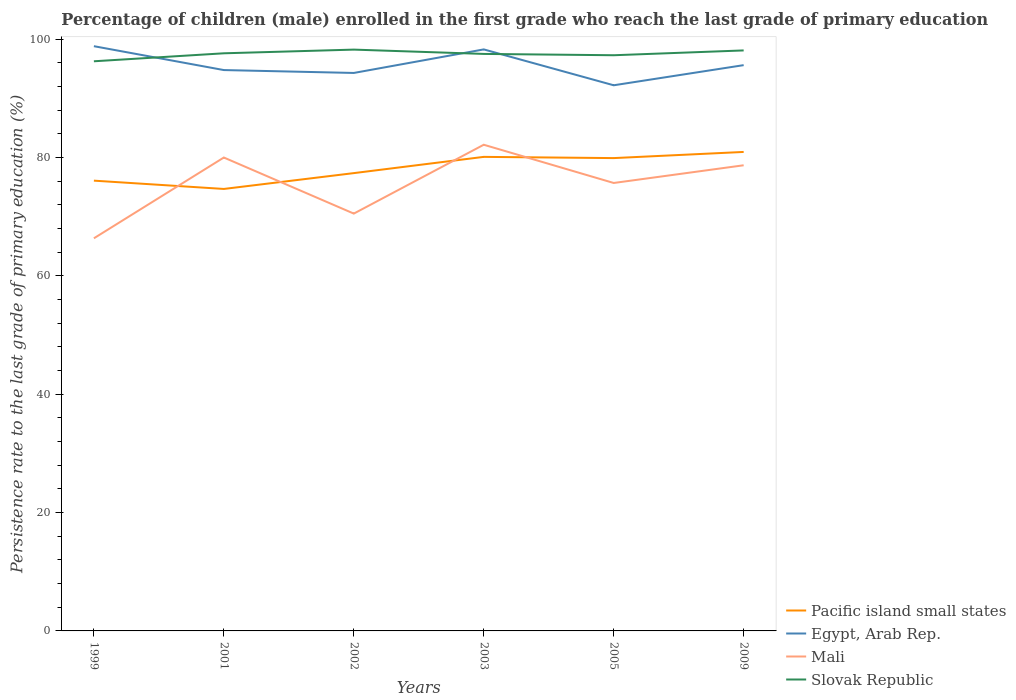Across all years, what is the maximum persistence rate of children in Slovak Republic?
Provide a short and direct response. 96.26. What is the total persistence rate of children in Mali in the graph?
Make the answer very short. -2.99. What is the difference between the highest and the second highest persistence rate of children in Pacific island small states?
Give a very brief answer. 6.25. What is the difference between the highest and the lowest persistence rate of children in Slovak Republic?
Ensure brevity in your answer.  4. How many years are there in the graph?
Ensure brevity in your answer.  6. Are the values on the major ticks of Y-axis written in scientific E-notation?
Ensure brevity in your answer.  No. Does the graph contain grids?
Your answer should be compact. No. Where does the legend appear in the graph?
Your answer should be very brief. Bottom right. How are the legend labels stacked?
Provide a short and direct response. Vertical. What is the title of the graph?
Your answer should be compact. Percentage of children (male) enrolled in the first grade who reach the last grade of primary education. What is the label or title of the X-axis?
Make the answer very short. Years. What is the label or title of the Y-axis?
Give a very brief answer. Persistence rate to the last grade of primary education (%). What is the Persistence rate to the last grade of primary education (%) in Pacific island small states in 1999?
Your answer should be compact. 76.08. What is the Persistence rate to the last grade of primary education (%) of Egypt, Arab Rep. in 1999?
Provide a short and direct response. 98.81. What is the Persistence rate to the last grade of primary education (%) in Mali in 1999?
Your answer should be compact. 66.34. What is the Persistence rate to the last grade of primary education (%) of Slovak Republic in 1999?
Provide a succinct answer. 96.26. What is the Persistence rate to the last grade of primary education (%) of Pacific island small states in 2001?
Make the answer very short. 74.68. What is the Persistence rate to the last grade of primary education (%) in Egypt, Arab Rep. in 2001?
Ensure brevity in your answer.  94.77. What is the Persistence rate to the last grade of primary education (%) in Mali in 2001?
Your answer should be compact. 79.99. What is the Persistence rate to the last grade of primary education (%) in Slovak Republic in 2001?
Provide a succinct answer. 97.6. What is the Persistence rate to the last grade of primary education (%) in Pacific island small states in 2002?
Ensure brevity in your answer.  77.36. What is the Persistence rate to the last grade of primary education (%) in Egypt, Arab Rep. in 2002?
Your answer should be very brief. 94.28. What is the Persistence rate to the last grade of primary education (%) in Mali in 2002?
Your response must be concise. 70.52. What is the Persistence rate to the last grade of primary education (%) in Slovak Republic in 2002?
Keep it short and to the point. 98.23. What is the Persistence rate to the last grade of primary education (%) in Pacific island small states in 2003?
Provide a succinct answer. 80.1. What is the Persistence rate to the last grade of primary education (%) of Egypt, Arab Rep. in 2003?
Give a very brief answer. 98.26. What is the Persistence rate to the last grade of primary education (%) in Mali in 2003?
Your answer should be compact. 82.15. What is the Persistence rate to the last grade of primary education (%) of Slovak Republic in 2003?
Provide a short and direct response. 97.5. What is the Persistence rate to the last grade of primary education (%) of Pacific island small states in 2005?
Your response must be concise. 79.89. What is the Persistence rate to the last grade of primary education (%) in Egypt, Arab Rep. in 2005?
Your answer should be compact. 92.2. What is the Persistence rate to the last grade of primary education (%) in Mali in 2005?
Keep it short and to the point. 75.69. What is the Persistence rate to the last grade of primary education (%) in Slovak Republic in 2005?
Your response must be concise. 97.27. What is the Persistence rate to the last grade of primary education (%) in Pacific island small states in 2009?
Your answer should be very brief. 80.94. What is the Persistence rate to the last grade of primary education (%) of Egypt, Arab Rep. in 2009?
Keep it short and to the point. 95.6. What is the Persistence rate to the last grade of primary education (%) of Mali in 2009?
Keep it short and to the point. 78.68. What is the Persistence rate to the last grade of primary education (%) in Slovak Republic in 2009?
Provide a short and direct response. 98.09. Across all years, what is the maximum Persistence rate to the last grade of primary education (%) of Pacific island small states?
Provide a succinct answer. 80.94. Across all years, what is the maximum Persistence rate to the last grade of primary education (%) of Egypt, Arab Rep.?
Provide a short and direct response. 98.81. Across all years, what is the maximum Persistence rate to the last grade of primary education (%) of Mali?
Provide a succinct answer. 82.15. Across all years, what is the maximum Persistence rate to the last grade of primary education (%) in Slovak Republic?
Make the answer very short. 98.23. Across all years, what is the minimum Persistence rate to the last grade of primary education (%) of Pacific island small states?
Your response must be concise. 74.68. Across all years, what is the minimum Persistence rate to the last grade of primary education (%) in Egypt, Arab Rep.?
Make the answer very short. 92.2. Across all years, what is the minimum Persistence rate to the last grade of primary education (%) in Mali?
Keep it short and to the point. 66.34. Across all years, what is the minimum Persistence rate to the last grade of primary education (%) in Slovak Republic?
Provide a short and direct response. 96.26. What is the total Persistence rate to the last grade of primary education (%) of Pacific island small states in the graph?
Offer a terse response. 469.05. What is the total Persistence rate to the last grade of primary education (%) in Egypt, Arab Rep. in the graph?
Keep it short and to the point. 573.92. What is the total Persistence rate to the last grade of primary education (%) in Mali in the graph?
Your answer should be very brief. 453.38. What is the total Persistence rate to the last grade of primary education (%) of Slovak Republic in the graph?
Keep it short and to the point. 584.95. What is the difference between the Persistence rate to the last grade of primary education (%) in Pacific island small states in 1999 and that in 2001?
Make the answer very short. 1.4. What is the difference between the Persistence rate to the last grade of primary education (%) of Egypt, Arab Rep. in 1999 and that in 2001?
Offer a very short reply. 4.04. What is the difference between the Persistence rate to the last grade of primary education (%) in Mali in 1999 and that in 2001?
Keep it short and to the point. -13.65. What is the difference between the Persistence rate to the last grade of primary education (%) of Slovak Republic in 1999 and that in 2001?
Offer a terse response. -1.35. What is the difference between the Persistence rate to the last grade of primary education (%) of Pacific island small states in 1999 and that in 2002?
Make the answer very short. -1.27. What is the difference between the Persistence rate to the last grade of primary education (%) of Egypt, Arab Rep. in 1999 and that in 2002?
Ensure brevity in your answer.  4.52. What is the difference between the Persistence rate to the last grade of primary education (%) of Mali in 1999 and that in 2002?
Your answer should be very brief. -4.18. What is the difference between the Persistence rate to the last grade of primary education (%) of Slovak Republic in 1999 and that in 2002?
Give a very brief answer. -1.97. What is the difference between the Persistence rate to the last grade of primary education (%) in Pacific island small states in 1999 and that in 2003?
Offer a terse response. -4.02. What is the difference between the Persistence rate to the last grade of primary education (%) in Egypt, Arab Rep. in 1999 and that in 2003?
Your answer should be compact. 0.54. What is the difference between the Persistence rate to the last grade of primary education (%) in Mali in 1999 and that in 2003?
Offer a terse response. -15.81. What is the difference between the Persistence rate to the last grade of primary education (%) in Slovak Republic in 1999 and that in 2003?
Your response must be concise. -1.24. What is the difference between the Persistence rate to the last grade of primary education (%) in Pacific island small states in 1999 and that in 2005?
Keep it short and to the point. -3.81. What is the difference between the Persistence rate to the last grade of primary education (%) in Egypt, Arab Rep. in 1999 and that in 2005?
Your response must be concise. 6.61. What is the difference between the Persistence rate to the last grade of primary education (%) in Mali in 1999 and that in 2005?
Provide a short and direct response. -9.35. What is the difference between the Persistence rate to the last grade of primary education (%) of Slovak Republic in 1999 and that in 2005?
Make the answer very short. -1.02. What is the difference between the Persistence rate to the last grade of primary education (%) in Pacific island small states in 1999 and that in 2009?
Make the answer very short. -4.85. What is the difference between the Persistence rate to the last grade of primary education (%) of Egypt, Arab Rep. in 1999 and that in 2009?
Keep it short and to the point. 3.2. What is the difference between the Persistence rate to the last grade of primary education (%) of Mali in 1999 and that in 2009?
Your answer should be very brief. -12.34. What is the difference between the Persistence rate to the last grade of primary education (%) in Slovak Republic in 1999 and that in 2009?
Offer a very short reply. -1.84. What is the difference between the Persistence rate to the last grade of primary education (%) of Pacific island small states in 2001 and that in 2002?
Provide a short and direct response. -2.67. What is the difference between the Persistence rate to the last grade of primary education (%) in Egypt, Arab Rep. in 2001 and that in 2002?
Keep it short and to the point. 0.49. What is the difference between the Persistence rate to the last grade of primary education (%) in Mali in 2001 and that in 2002?
Offer a very short reply. 9.48. What is the difference between the Persistence rate to the last grade of primary education (%) in Slovak Republic in 2001 and that in 2002?
Provide a succinct answer. -0.62. What is the difference between the Persistence rate to the last grade of primary education (%) of Pacific island small states in 2001 and that in 2003?
Make the answer very short. -5.42. What is the difference between the Persistence rate to the last grade of primary education (%) in Egypt, Arab Rep. in 2001 and that in 2003?
Ensure brevity in your answer.  -3.49. What is the difference between the Persistence rate to the last grade of primary education (%) of Mali in 2001 and that in 2003?
Offer a very short reply. -2.16. What is the difference between the Persistence rate to the last grade of primary education (%) of Slovak Republic in 2001 and that in 2003?
Offer a very short reply. 0.11. What is the difference between the Persistence rate to the last grade of primary education (%) of Pacific island small states in 2001 and that in 2005?
Give a very brief answer. -5.21. What is the difference between the Persistence rate to the last grade of primary education (%) of Egypt, Arab Rep. in 2001 and that in 2005?
Offer a very short reply. 2.57. What is the difference between the Persistence rate to the last grade of primary education (%) in Mali in 2001 and that in 2005?
Your answer should be very brief. 4.3. What is the difference between the Persistence rate to the last grade of primary education (%) of Slovak Republic in 2001 and that in 2005?
Give a very brief answer. 0.33. What is the difference between the Persistence rate to the last grade of primary education (%) of Pacific island small states in 2001 and that in 2009?
Your answer should be very brief. -6.25. What is the difference between the Persistence rate to the last grade of primary education (%) of Egypt, Arab Rep. in 2001 and that in 2009?
Offer a very short reply. -0.83. What is the difference between the Persistence rate to the last grade of primary education (%) of Mali in 2001 and that in 2009?
Keep it short and to the point. 1.31. What is the difference between the Persistence rate to the last grade of primary education (%) of Slovak Republic in 2001 and that in 2009?
Your response must be concise. -0.49. What is the difference between the Persistence rate to the last grade of primary education (%) of Pacific island small states in 2002 and that in 2003?
Give a very brief answer. -2.75. What is the difference between the Persistence rate to the last grade of primary education (%) of Egypt, Arab Rep. in 2002 and that in 2003?
Give a very brief answer. -3.98. What is the difference between the Persistence rate to the last grade of primary education (%) in Mali in 2002 and that in 2003?
Offer a terse response. -11.63. What is the difference between the Persistence rate to the last grade of primary education (%) in Slovak Republic in 2002 and that in 2003?
Your answer should be very brief. 0.73. What is the difference between the Persistence rate to the last grade of primary education (%) in Pacific island small states in 2002 and that in 2005?
Provide a succinct answer. -2.54. What is the difference between the Persistence rate to the last grade of primary education (%) in Egypt, Arab Rep. in 2002 and that in 2005?
Ensure brevity in your answer.  2.08. What is the difference between the Persistence rate to the last grade of primary education (%) in Mali in 2002 and that in 2005?
Ensure brevity in your answer.  -5.17. What is the difference between the Persistence rate to the last grade of primary education (%) in Slovak Republic in 2002 and that in 2005?
Provide a succinct answer. 0.95. What is the difference between the Persistence rate to the last grade of primary education (%) of Pacific island small states in 2002 and that in 2009?
Offer a very short reply. -3.58. What is the difference between the Persistence rate to the last grade of primary education (%) in Egypt, Arab Rep. in 2002 and that in 2009?
Keep it short and to the point. -1.32. What is the difference between the Persistence rate to the last grade of primary education (%) of Mali in 2002 and that in 2009?
Your answer should be compact. -8.17. What is the difference between the Persistence rate to the last grade of primary education (%) of Slovak Republic in 2002 and that in 2009?
Ensure brevity in your answer.  0.14. What is the difference between the Persistence rate to the last grade of primary education (%) of Pacific island small states in 2003 and that in 2005?
Offer a terse response. 0.21. What is the difference between the Persistence rate to the last grade of primary education (%) of Egypt, Arab Rep. in 2003 and that in 2005?
Your answer should be very brief. 6.06. What is the difference between the Persistence rate to the last grade of primary education (%) in Mali in 2003 and that in 2005?
Offer a very short reply. 6.46. What is the difference between the Persistence rate to the last grade of primary education (%) of Slovak Republic in 2003 and that in 2005?
Offer a very short reply. 0.22. What is the difference between the Persistence rate to the last grade of primary education (%) in Pacific island small states in 2003 and that in 2009?
Make the answer very short. -0.83. What is the difference between the Persistence rate to the last grade of primary education (%) in Egypt, Arab Rep. in 2003 and that in 2009?
Your answer should be very brief. 2.66. What is the difference between the Persistence rate to the last grade of primary education (%) in Mali in 2003 and that in 2009?
Provide a succinct answer. 3.47. What is the difference between the Persistence rate to the last grade of primary education (%) in Slovak Republic in 2003 and that in 2009?
Offer a terse response. -0.59. What is the difference between the Persistence rate to the last grade of primary education (%) of Pacific island small states in 2005 and that in 2009?
Keep it short and to the point. -1.04. What is the difference between the Persistence rate to the last grade of primary education (%) of Egypt, Arab Rep. in 2005 and that in 2009?
Give a very brief answer. -3.4. What is the difference between the Persistence rate to the last grade of primary education (%) in Mali in 2005 and that in 2009?
Your answer should be very brief. -2.99. What is the difference between the Persistence rate to the last grade of primary education (%) of Slovak Republic in 2005 and that in 2009?
Give a very brief answer. -0.82. What is the difference between the Persistence rate to the last grade of primary education (%) in Pacific island small states in 1999 and the Persistence rate to the last grade of primary education (%) in Egypt, Arab Rep. in 2001?
Ensure brevity in your answer.  -18.69. What is the difference between the Persistence rate to the last grade of primary education (%) of Pacific island small states in 1999 and the Persistence rate to the last grade of primary education (%) of Mali in 2001?
Provide a short and direct response. -3.91. What is the difference between the Persistence rate to the last grade of primary education (%) of Pacific island small states in 1999 and the Persistence rate to the last grade of primary education (%) of Slovak Republic in 2001?
Ensure brevity in your answer.  -21.52. What is the difference between the Persistence rate to the last grade of primary education (%) of Egypt, Arab Rep. in 1999 and the Persistence rate to the last grade of primary education (%) of Mali in 2001?
Your response must be concise. 18.81. What is the difference between the Persistence rate to the last grade of primary education (%) in Egypt, Arab Rep. in 1999 and the Persistence rate to the last grade of primary education (%) in Slovak Republic in 2001?
Your answer should be compact. 1.2. What is the difference between the Persistence rate to the last grade of primary education (%) in Mali in 1999 and the Persistence rate to the last grade of primary education (%) in Slovak Republic in 2001?
Your answer should be compact. -31.26. What is the difference between the Persistence rate to the last grade of primary education (%) in Pacific island small states in 1999 and the Persistence rate to the last grade of primary education (%) in Egypt, Arab Rep. in 2002?
Make the answer very short. -18.2. What is the difference between the Persistence rate to the last grade of primary education (%) of Pacific island small states in 1999 and the Persistence rate to the last grade of primary education (%) of Mali in 2002?
Make the answer very short. 5.57. What is the difference between the Persistence rate to the last grade of primary education (%) in Pacific island small states in 1999 and the Persistence rate to the last grade of primary education (%) in Slovak Republic in 2002?
Keep it short and to the point. -22.14. What is the difference between the Persistence rate to the last grade of primary education (%) in Egypt, Arab Rep. in 1999 and the Persistence rate to the last grade of primary education (%) in Mali in 2002?
Offer a very short reply. 28.29. What is the difference between the Persistence rate to the last grade of primary education (%) in Egypt, Arab Rep. in 1999 and the Persistence rate to the last grade of primary education (%) in Slovak Republic in 2002?
Your answer should be compact. 0.58. What is the difference between the Persistence rate to the last grade of primary education (%) in Mali in 1999 and the Persistence rate to the last grade of primary education (%) in Slovak Republic in 2002?
Make the answer very short. -31.88. What is the difference between the Persistence rate to the last grade of primary education (%) of Pacific island small states in 1999 and the Persistence rate to the last grade of primary education (%) of Egypt, Arab Rep. in 2003?
Your response must be concise. -22.18. What is the difference between the Persistence rate to the last grade of primary education (%) in Pacific island small states in 1999 and the Persistence rate to the last grade of primary education (%) in Mali in 2003?
Give a very brief answer. -6.07. What is the difference between the Persistence rate to the last grade of primary education (%) of Pacific island small states in 1999 and the Persistence rate to the last grade of primary education (%) of Slovak Republic in 2003?
Ensure brevity in your answer.  -21.41. What is the difference between the Persistence rate to the last grade of primary education (%) in Egypt, Arab Rep. in 1999 and the Persistence rate to the last grade of primary education (%) in Mali in 2003?
Provide a succinct answer. 16.65. What is the difference between the Persistence rate to the last grade of primary education (%) in Egypt, Arab Rep. in 1999 and the Persistence rate to the last grade of primary education (%) in Slovak Republic in 2003?
Make the answer very short. 1.31. What is the difference between the Persistence rate to the last grade of primary education (%) in Mali in 1999 and the Persistence rate to the last grade of primary education (%) in Slovak Republic in 2003?
Provide a short and direct response. -31.16. What is the difference between the Persistence rate to the last grade of primary education (%) of Pacific island small states in 1999 and the Persistence rate to the last grade of primary education (%) of Egypt, Arab Rep. in 2005?
Provide a succinct answer. -16.12. What is the difference between the Persistence rate to the last grade of primary education (%) of Pacific island small states in 1999 and the Persistence rate to the last grade of primary education (%) of Mali in 2005?
Make the answer very short. 0.39. What is the difference between the Persistence rate to the last grade of primary education (%) of Pacific island small states in 1999 and the Persistence rate to the last grade of primary education (%) of Slovak Republic in 2005?
Provide a short and direct response. -21.19. What is the difference between the Persistence rate to the last grade of primary education (%) in Egypt, Arab Rep. in 1999 and the Persistence rate to the last grade of primary education (%) in Mali in 2005?
Offer a very short reply. 23.11. What is the difference between the Persistence rate to the last grade of primary education (%) of Egypt, Arab Rep. in 1999 and the Persistence rate to the last grade of primary education (%) of Slovak Republic in 2005?
Your answer should be very brief. 1.53. What is the difference between the Persistence rate to the last grade of primary education (%) in Mali in 1999 and the Persistence rate to the last grade of primary education (%) in Slovak Republic in 2005?
Your answer should be very brief. -30.93. What is the difference between the Persistence rate to the last grade of primary education (%) of Pacific island small states in 1999 and the Persistence rate to the last grade of primary education (%) of Egypt, Arab Rep. in 2009?
Make the answer very short. -19.52. What is the difference between the Persistence rate to the last grade of primary education (%) in Pacific island small states in 1999 and the Persistence rate to the last grade of primary education (%) in Mali in 2009?
Ensure brevity in your answer.  -2.6. What is the difference between the Persistence rate to the last grade of primary education (%) in Pacific island small states in 1999 and the Persistence rate to the last grade of primary education (%) in Slovak Republic in 2009?
Offer a terse response. -22.01. What is the difference between the Persistence rate to the last grade of primary education (%) in Egypt, Arab Rep. in 1999 and the Persistence rate to the last grade of primary education (%) in Mali in 2009?
Offer a very short reply. 20.12. What is the difference between the Persistence rate to the last grade of primary education (%) in Egypt, Arab Rep. in 1999 and the Persistence rate to the last grade of primary education (%) in Slovak Republic in 2009?
Provide a succinct answer. 0.72. What is the difference between the Persistence rate to the last grade of primary education (%) in Mali in 1999 and the Persistence rate to the last grade of primary education (%) in Slovak Republic in 2009?
Provide a short and direct response. -31.75. What is the difference between the Persistence rate to the last grade of primary education (%) in Pacific island small states in 2001 and the Persistence rate to the last grade of primary education (%) in Egypt, Arab Rep. in 2002?
Make the answer very short. -19.6. What is the difference between the Persistence rate to the last grade of primary education (%) of Pacific island small states in 2001 and the Persistence rate to the last grade of primary education (%) of Mali in 2002?
Offer a very short reply. 4.17. What is the difference between the Persistence rate to the last grade of primary education (%) of Pacific island small states in 2001 and the Persistence rate to the last grade of primary education (%) of Slovak Republic in 2002?
Ensure brevity in your answer.  -23.54. What is the difference between the Persistence rate to the last grade of primary education (%) in Egypt, Arab Rep. in 2001 and the Persistence rate to the last grade of primary education (%) in Mali in 2002?
Your answer should be very brief. 24.25. What is the difference between the Persistence rate to the last grade of primary education (%) of Egypt, Arab Rep. in 2001 and the Persistence rate to the last grade of primary education (%) of Slovak Republic in 2002?
Keep it short and to the point. -3.46. What is the difference between the Persistence rate to the last grade of primary education (%) of Mali in 2001 and the Persistence rate to the last grade of primary education (%) of Slovak Republic in 2002?
Give a very brief answer. -18.23. What is the difference between the Persistence rate to the last grade of primary education (%) in Pacific island small states in 2001 and the Persistence rate to the last grade of primary education (%) in Egypt, Arab Rep. in 2003?
Ensure brevity in your answer.  -23.58. What is the difference between the Persistence rate to the last grade of primary education (%) of Pacific island small states in 2001 and the Persistence rate to the last grade of primary education (%) of Mali in 2003?
Your answer should be compact. -7.47. What is the difference between the Persistence rate to the last grade of primary education (%) of Pacific island small states in 2001 and the Persistence rate to the last grade of primary education (%) of Slovak Republic in 2003?
Your answer should be compact. -22.82. What is the difference between the Persistence rate to the last grade of primary education (%) of Egypt, Arab Rep. in 2001 and the Persistence rate to the last grade of primary education (%) of Mali in 2003?
Your answer should be compact. 12.62. What is the difference between the Persistence rate to the last grade of primary education (%) in Egypt, Arab Rep. in 2001 and the Persistence rate to the last grade of primary education (%) in Slovak Republic in 2003?
Make the answer very short. -2.73. What is the difference between the Persistence rate to the last grade of primary education (%) of Mali in 2001 and the Persistence rate to the last grade of primary education (%) of Slovak Republic in 2003?
Your answer should be compact. -17.5. What is the difference between the Persistence rate to the last grade of primary education (%) of Pacific island small states in 2001 and the Persistence rate to the last grade of primary education (%) of Egypt, Arab Rep. in 2005?
Ensure brevity in your answer.  -17.52. What is the difference between the Persistence rate to the last grade of primary education (%) of Pacific island small states in 2001 and the Persistence rate to the last grade of primary education (%) of Mali in 2005?
Provide a short and direct response. -1.01. What is the difference between the Persistence rate to the last grade of primary education (%) of Pacific island small states in 2001 and the Persistence rate to the last grade of primary education (%) of Slovak Republic in 2005?
Give a very brief answer. -22.59. What is the difference between the Persistence rate to the last grade of primary education (%) of Egypt, Arab Rep. in 2001 and the Persistence rate to the last grade of primary education (%) of Mali in 2005?
Keep it short and to the point. 19.08. What is the difference between the Persistence rate to the last grade of primary education (%) of Egypt, Arab Rep. in 2001 and the Persistence rate to the last grade of primary education (%) of Slovak Republic in 2005?
Make the answer very short. -2.5. What is the difference between the Persistence rate to the last grade of primary education (%) of Mali in 2001 and the Persistence rate to the last grade of primary education (%) of Slovak Republic in 2005?
Your answer should be very brief. -17.28. What is the difference between the Persistence rate to the last grade of primary education (%) in Pacific island small states in 2001 and the Persistence rate to the last grade of primary education (%) in Egypt, Arab Rep. in 2009?
Provide a succinct answer. -20.92. What is the difference between the Persistence rate to the last grade of primary education (%) in Pacific island small states in 2001 and the Persistence rate to the last grade of primary education (%) in Mali in 2009?
Provide a succinct answer. -4. What is the difference between the Persistence rate to the last grade of primary education (%) of Pacific island small states in 2001 and the Persistence rate to the last grade of primary education (%) of Slovak Republic in 2009?
Provide a succinct answer. -23.41. What is the difference between the Persistence rate to the last grade of primary education (%) in Egypt, Arab Rep. in 2001 and the Persistence rate to the last grade of primary education (%) in Mali in 2009?
Your answer should be compact. 16.09. What is the difference between the Persistence rate to the last grade of primary education (%) in Egypt, Arab Rep. in 2001 and the Persistence rate to the last grade of primary education (%) in Slovak Republic in 2009?
Your answer should be compact. -3.32. What is the difference between the Persistence rate to the last grade of primary education (%) of Mali in 2001 and the Persistence rate to the last grade of primary education (%) of Slovak Republic in 2009?
Your answer should be very brief. -18.1. What is the difference between the Persistence rate to the last grade of primary education (%) in Pacific island small states in 2002 and the Persistence rate to the last grade of primary education (%) in Egypt, Arab Rep. in 2003?
Your answer should be very brief. -20.91. What is the difference between the Persistence rate to the last grade of primary education (%) of Pacific island small states in 2002 and the Persistence rate to the last grade of primary education (%) of Mali in 2003?
Your response must be concise. -4.79. What is the difference between the Persistence rate to the last grade of primary education (%) in Pacific island small states in 2002 and the Persistence rate to the last grade of primary education (%) in Slovak Republic in 2003?
Your response must be concise. -20.14. What is the difference between the Persistence rate to the last grade of primary education (%) in Egypt, Arab Rep. in 2002 and the Persistence rate to the last grade of primary education (%) in Mali in 2003?
Make the answer very short. 12.13. What is the difference between the Persistence rate to the last grade of primary education (%) of Egypt, Arab Rep. in 2002 and the Persistence rate to the last grade of primary education (%) of Slovak Republic in 2003?
Give a very brief answer. -3.22. What is the difference between the Persistence rate to the last grade of primary education (%) of Mali in 2002 and the Persistence rate to the last grade of primary education (%) of Slovak Republic in 2003?
Ensure brevity in your answer.  -26.98. What is the difference between the Persistence rate to the last grade of primary education (%) of Pacific island small states in 2002 and the Persistence rate to the last grade of primary education (%) of Egypt, Arab Rep. in 2005?
Give a very brief answer. -14.84. What is the difference between the Persistence rate to the last grade of primary education (%) of Pacific island small states in 2002 and the Persistence rate to the last grade of primary education (%) of Mali in 2005?
Offer a terse response. 1.66. What is the difference between the Persistence rate to the last grade of primary education (%) of Pacific island small states in 2002 and the Persistence rate to the last grade of primary education (%) of Slovak Republic in 2005?
Offer a very short reply. -19.92. What is the difference between the Persistence rate to the last grade of primary education (%) of Egypt, Arab Rep. in 2002 and the Persistence rate to the last grade of primary education (%) of Mali in 2005?
Your answer should be very brief. 18.59. What is the difference between the Persistence rate to the last grade of primary education (%) in Egypt, Arab Rep. in 2002 and the Persistence rate to the last grade of primary education (%) in Slovak Republic in 2005?
Your answer should be compact. -2.99. What is the difference between the Persistence rate to the last grade of primary education (%) of Mali in 2002 and the Persistence rate to the last grade of primary education (%) of Slovak Republic in 2005?
Ensure brevity in your answer.  -26.76. What is the difference between the Persistence rate to the last grade of primary education (%) of Pacific island small states in 2002 and the Persistence rate to the last grade of primary education (%) of Egypt, Arab Rep. in 2009?
Offer a very short reply. -18.25. What is the difference between the Persistence rate to the last grade of primary education (%) in Pacific island small states in 2002 and the Persistence rate to the last grade of primary education (%) in Mali in 2009?
Offer a terse response. -1.33. What is the difference between the Persistence rate to the last grade of primary education (%) of Pacific island small states in 2002 and the Persistence rate to the last grade of primary education (%) of Slovak Republic in 2009?
Provide a succinct answer. -20.73. What is the difference between the Persistence rate to the last grade of primary education (%) in Egypt, Arab Rep. in 2002 and the Persistence rate to the last grade of primary education (%) in Mali in 2009?
Make the answer very short. 15.6. What is the difference between the Persistence rate to the last grade of primary education (%) of Egypt, Arab Rep. in 2002 and the Persistence rate to the last grade of primary education (%) of Slovak Republic in 2009?
Your answer should be very brief. -3.81. What is the difference between the Persistence rate to the last grade of primary education (%) in Mali in 2002 and the Persistence rate to the last grade of primary education (%) in Slovak Republic in 2009?
Give a very brief answer. -27.57. What is the difference between the Persistence rate to the last grade of primary education (%) in Pacific island small states in 2003 and the Persistence rate to the last grade of primary education (%) in Egypt, Arab Rep. in 2005?
Your response must be concise. -12.1. What is the difference between the Persistence rate to the last grade of primary education (%) in Pacific island small states in 2003 and the Persistence rate to the last grade of primary education (%) in Mali in 2005?
Provide a succinct answer. 4.41. What is the difference between the Persistence rate to the last grade of primary education (%) in Pacific island small states in 2003 and the Persistence rate to the last grade of primary education (%) in Slovak Republic in 2005?
Make the answer very short. -17.17. What is the difference between the Persistence rate to the last grade of primary education (%) in Egypt, Arab Rep. in 2003 and the Persistence rate to the last grade of primary education (%) in Mali in 2005?
Make the answer very short. 22.57. What is the difference between the Persistence rate to the last grade of primary education (%) in Egypt, Arab Rep. in 2003 and the Persistence rate to the last grade of primary education (%) in Slovak Republic in 2005?
Provide a succinct answer. 0.99. What is the difference between the Persistence rate to the last grade of primary education (%) in Mali in 2003 and the Persistence rate to the last grade of primary education (%) in Slovak Republic in 2005?
Give a very brief answer. -15.12. What is the difference between the Persistence rate to the last grade of primary education (%) of Pacific island small states in 2003 and the Persistence rate to the last grade of primary education (%) of Egypt, Arab Rep. in 2009?
Your answer should be very brief. -15.5. What is the difference between the Persistence rate to the last grade of primary education (%) in Pacific island small states in 2003 and the Persistence rate to the last grade of primary education (%) in Mali in 2009?
Offer a terse response. 1.42. What is the difference between the Persistence rate to the last grade of primary education (%) in Pacific island small states in 2003 and the Persistence rate to the last grade of primary education (%) in Slovak Republic in 2009?
Ensure brevity in your answer.  -17.99. What is the difference between the Persistence rate to the last grade of primary education (%) of Egypt, Arab Rep. in 2003 and the Persistence rate to the last grade of primary education (%) of Mali in 2009?
Make the answer very short. 19.58. What is the difference between the Persistence rate to the last grade of primary education (%) in Egypt, Arab Rep. in 2003 and the Persistence rate to the last grade of primary education (%) in Slovak Republic in 2009?
Ensure brevity in your answer.  0.17. What is the difference between the Persistence rate to the last grade of primary education (%) of Mali in 2003 and the Persistence rate to the last grade of primary education (%) of Slovak Republic in 2009?
Offer a terse response. -15.94. What is the difference between the Persistence rate to the last grade of primary education (%) in Pacific island small states in 2005 and the Persistence rate to the last grade of primary education (%) in Egypt, Arab Rep. in 2009?
Provide a succinct answer. -15.71. What is the difference between the Persistence rate to the last grade of primary education (%) of Pacific island small states in 2005 and the Persistence rate to the last grade of primary education (%) of Mali in 2009?
Your answer should be compact. 1.21. What is the difference between the Persistence rate to the last grade of primary education (%) of Pacific island small states in 2005 and the Persistence rate to the last grade of primary education (%) of Slovak Republic in 2009?
Make the answer very short. -18.2. What is the difference between the Persistence rate to the last grade of primary education (%) of Egypt, Arab Rep. in 2005 and the Persistence rate to the last grade of primary education (%) of Mali in 2009?
Ensure brevity in your answer.  13.52. What is the difference between the Persistence rate to the last grade of primary education (%) of Egypt, Arab Rep. in 2005 and the Persistence rate to the last grade of primary education (%) of Slovak Republic in 2009?
Offer a very short reply. -5.89. What is the difference between the Persistence rate to the last grade of primary education (%) in Mali in 2005 and the Persistence rate to the last grade of primary education (%) in Slovak Republic in 2009?
Your response must be concise. -22.4. What is the average Persistence rate to the last grade of primary education (%) of Pacific island small states per year?
Offer a very short reply. 78.18. What is the average Persistence rate to the last grade of primary education (%) in Egypt, Arab Rep. per year?
Ensure brevity in your answer.  95.65. What is the average Persistence rate to the last grade of primary education (%) in Mali per year?
Give a very brief answer. 75.56. What is the average Persistence rate to the last grade of primary education (%) of Slovak Republic per year?
Your response must be concise. 97.49. In the year 1999, what is the difference between the Persistence rate to the last grade of primary education (%) of Pacific island small states and Persistence rate to the last grade of primary education (%) of Egypt, Arab Rep.?
Your answer should be very brief. -22.72. In the year 1999, what is the difference between the Persistence rate to the last grade of primary education (%) of Pacific island small states and Persistence rate to the last grade of primary education (%) of Mali?
Provide a succinct answer. 9.74. In the year 1999, what is the difference between the Persistence rate to the last grade of primary education (%) in Pacific island small states and Persistence rate to the last grade of primary education (%) in Slovak Republic?
Your answer should be compact. -20.17. In the year 1999, what is the difference between the Persistence rate to the last grade of primary education (%) of Egypt, Arab Rep. and Persistence rate to the last grade of primary education (%) of Mali?
Provide a short and direct response. 32.46. In the year 1999, what is the difference between the Persistence rate to the last grade of primary education (%) of Egypt, Arab Rep. and Persistence rate to the last grade of primary education (%) of Slovak Republic?
Provide a succinct answer. 2.55. In the year 1999, what is the difference between the Persistence rate to the last grade of primary education (%) in Mali and Persistence rate to the last grade of primary education (%) in Slovak Republic?
Offer a terse response. -29.91. In the year 2001, what is the difference between the Persistence rate to the last grade of primary education (%) of Pacific island small states and Persistence rate to the last grade of primary education (%) of Egypt, Arab Rep.?
Your answer should be very brief. -20.09. In the year 2001, what is the difference between the Persistence rate to the last grade of primary education (%) of Pacific island small states and Persistence rate to the last grade of primary education (%) of Mali?
Make the answer very short. -5.31. In the year 2001, what is the difference between the Persistence rate to the last grade of primary education (%) of Pacific island small states and Persistence rate to the last grade of primary education (%) of Slovak Republic?
Your answer should be very brief. -22.92. In the year 2001, what is the difference between the Persistence rate to the last grade of primary education (%) of Egypt, Arab Rep. and Persistence rate to the last grade of primary education (%) of Mali?
Provide a short and direct response. 14.78. In the year 2001, what is the difference between the Persistence rate to the last grade of primary education (%) of Egypt, Arab Rep. and Persistence rate to the last grade of primary education (%) of Slovak Republic?
Your answer should be compact. -2.83. In the year 2001, what is the difference between the Persistence rate to the last grade of primary education (%) of Mali and Persistence rate to the last grade of primary education (%) of Slovak Republic?
Make the answer very short. -17.61. In the year 2002, what is the difference between the Persistence rate to the last grade of primary education (%) in Pacific island small states and Persistence rate to the last grade of primary education (%) in Egypt, Arab Rep.?
Keep it short and to the point. -16.93. In the year 2002, what is the difference between the Persistence rate to the last grade of primary education (%) in Pacific island small states and Persistence rate to the last grade of primary education (%) in Mali?
Your response must be concise. 6.84. In the year 2002, what is the difference between the Persistence rate to the last grade of primary education (%) of Pacific island small states and Persistence rate to the last grade of primary education (%) of Slovak Republic?
Your answer should be very brief. -20.87. In the year 2002, what is the difference between the Persistence rate to the last grade of primary education (%) of Egypt, Arab Rep. and Persistence rate to the last grade of primary education (%) of Mali?
Your response must be concise. 23.77. In the year 2002, what is the difference between the Persistence rate to the last grade of primary education (%) of Egypt, Arab Rep. and Persistence rate to the last grade of primary education (%) of Slovak Republic?
Your response must be concise. -3.94. In the year 2002, what is the difference between the Persistence rate to the last grade of primary education (%) in Mali and Persistence rate to the last grade of primary education (%) in Slovak Republic?
Your answer should be very brief. -27.71. In the year 2003, what is the difference between the Persistence rate to the last grade of primary education (%) of Pacific island small states and Persistence rate to the last grade of primary education (%) of Egypt, Arab Rep.?
Give a very brief answer. -18.16. In the year 2003, what is the difference between the Persistence rate to the last grade of primary education (%) of Pacific island small states and Persistence rate to the last grade of primary education (%) of Mali?
Give a very brief answer. -2.05. In the year 2003, what is the difference between the Persistence rate to the last grade of primary education (%) in Pacific island small states and Persistence rate to the last grade of primary education (%) in Slovak Republic?
Your answer should be very brief. -17.4. In the year 2003, what is the difference between the Persistence rate to the last grade of primary education (%) in Egypt, Arab Rep. and Persistence rate to the last grade of primary education (%) in Mali?
Provide a short and direct response. 16.11. In the year 2003, what is the difference between the Persistence rate to the last grade of primary education (%) of Egypt, Arab Rep. and Persistence rate to the last grade of primary education (%) of Slovak Republic?
Your answer should be very brief. 0.76. In the year 2003, what is the difference between the Persistence rate to the last grade of primary education (%) of Mali and Persistence rate to the last grade of primary education (%) of Slovak Republic?
Your answer should be very brief. -15.35. In the year 2005, what is the difference between the Persistence rate to the last grade of primary education (%) in Pacific island small states and Persistence rate to the last grade of primary education (%) in Egypt, Arab Rep.?
Provide a succinct answer. -12.31. In the year 2005, what is the difference between the Persistence rate to the last grade of primary education (%) in Pacific island small states and Persistence rate to the last grade of primary education (%) in Mali?
Provide a succinct answer. 4.2. In the year 2005, what is the difference between the Persistence rate to the last grade of primary education (%) in Pacific island small states and Persistence rate to the last grade of primary education (%) in Slovak Republic?
Make the answer very short. -17.38. In the year 2005, what is the difference between the Persistence rate to the last grade of primary education (%) in Egypt, Arab Rep. and Persistence rate to the last grade of primary education (%) in Mali?
Provide a succinct answer. 16.51. In the year 2005, what is the difference between the Persistence rate to the last grade of primary education (%) of Egypt, Arab Rep. and Persistence rate to the last grade of primary education (%) of Slovak Republic?
Make the answer very short. -5.07. In the year 2005, what is the difference between the Persistence rate to the last grade of primary education (%) of Mali and Persistence rate to the last grade of primary education (%) of Slovak Republic?
Your answer should be very brief. -21.58. In the year 2009, what is the difference between the Persistence rate to the last grade of primary education (%) in Pacific island small states and Persistence rate to the last grade of primary education (%) in Egypt, Arab Rep.?
Ensure brevity in your answer.  -14.67. In the year 2009, what is the difference between the Persistence rate to the last grade of primary education (%) in Pacific island small states and Persistence rate to the last grade of primary education (%) in Mali?
Your response must be concise. 2.25. In the year 2009, what is the difference between the Persistence rate to the last grade of primary education (%) in Pacific island small states and Persistence rate to the last grade of primary education (%) in Slovak Republic?
Your response must be concise. -17.15. In the year 2009, what is the difference between the Persistence rate to the last grade of primary education (%) of Egypt, Arab Rep. and Persistence rate to the last grade of primary education (%) of Mali?
Offer a terse response. 16.92. In the year 2009, what is the difference between the Persistence rate to the last grade of primary education (%) of Egypt, Arab Rep. and Persistence rate to the last grade of primary education (%) of Slovak Republic?
Provide a succinct answer. -2.49. In the year 2009, what is the difference between the Persistence rate to the last grade of primary education (%) of Mali and Persistence rate to the last grade of primary education (%) of Slovak Republic?
Provide a succinct answer. -19.41. What is the ratio of the Persistence rate to the last grade of primary education (%) of Pacific island small states in 1999 to that in 2001?
Provide a short and direct response. 1.02. What is the ratio of the Persistence rate to the last grade of primary education (%) in Egypt, Arab Rep. in 1999 to that in 2001?
Give a very brief answer. 1.04. What is the ratio of the Persistence rate to the last grade of primary education (%) in Mali in 1999 to that in 2001?
Your response must be concise. 0.83. What is the ratio of the Persistence rate to the last grade of primary education (%) in Slovak Republic in 1999 to that in 2001?
Your answer should be compact. 0.99. What is the ratio of the Persistence rate to the last grade of primary education (%) in Pacific island small states in 1999 to that in 2002?
Give a very brief answer. 0.98. What is the ratio of the Persistence rate to the last grade of primary education (%) of Egypt, Arab Rep. in 1999 to that in 2002?
Provide a succinct answer. 1.05. What is the ratio of the Persistence rate to the last grade of primary education (%) of Mali in 1999 to that in 2002?
Your answer should be very brief. 0.94. What is the ratio of the Persistence rate to the last grade of primary education (%) of Slovak Republic in 1999 to that in 2002?
Ensure brevity in your answer.  0.98. What is the ratio of the Persistence rate to the last grade of primary education (%) in Pacific island small states in 1999 to that in 2003?
Provide a short and direct response. 0.95. What is the ratio of the Persistence rate to the last grade of primary education (%) of Egypt, Arab Rep. in 1999 to that in 2003?
Offer a very short reply. 1.01. What is the ratio of the Persistence rate to the last grade of primary education (%) of Mali in 1999 to that in 2003?
Ensure brevity in your answer.  0.81. What is the ratio of the Persistence rate to the last grade of primary education (%) in Slovak Republic in 1999 to that in 2003?
Ensure brevity in your answer.  0.99. What is the ratio of the Persistence rate to the last grade of primary education (%) in Pacific island small states in 1999 to that in 2005?
Give a very brief answer. 0.95. What is the ratio of the Persistence rate to the last grade of primary education (%) of Egypt, Arab Rep. in 1999 to that in 2005?
Keep it short and to the point. 1.07. What is the ratio of the Persistence rate to the last grade of primary education (%) in Mali in 1999 to that in 2005?
Your answer should be very brief. 0.88. What is the ratio of the Persistence rate to the last grade of primary education (%) in Slovak Republic in 1999 to that in 2005?
Keep it short and to the point. 0.99. What is the ratio of the Persistence rate to the last grade of primary education (%) in Pacific island small states in 1999 to that in 2009?
Your answer should be very brief. 0.94. What is the ratio of the Persistence rate to the last grade of primary education (%) in Egypt, Arab Rep. in 1999 to that in 2009?
Offer a very short reply. 1.03. What is the ratio of the Persistence rate to the last grade of primary education (%) in Mali in 1999 to that in 2009?
Provide a short and direct response. 0.84. What is the ratio of the Persistence rate to the last grade of primary education (%) of Slovak Republic in 1999 to that in 2009?
Your response must be concise. 0.98. What is the ratio of the Persistence rate to the last grade of primary education (%) of Pacific island small states in 2001 to that in 2002?
Your answer should be compact. 0.97. What is the ratio of the Persistence rate to the last grade of primary education (%) of Mali in 2001 to that in 2002?
Keep it short and to the point. 1.13. What is the ratio of the Persistence rate to the last grade of primary education (%) in Slovak Republic in 2001 to that in 2002?
Your answer should be compact. 0.99. What is the ratio of the Persistence rate to the last grade of primary education (%) in Pacific island small states in 2001 to that in 2003?
Keep it short and to the point. 0.93. What is the ratio of the Persistence rate to the last grade of primary education (%) in Egypt, Arab Rep. in 2001 to that in 2003?
Make the answer very short. 0.96. What is the ratio of the Persistence rate to the last grade of primary education (%) of Mali in 2001 to that in 2003?
Offer a very short reply. 0.97. What is the ratio of the Persistence rate to the last grade of primary education (%) of Pacific island small states in 2001 to that in 2005?
Your answer should be very brief. 0.93. What is the ratio of the Persistence rate to the last grade of primary education (%) in Egypt, Arab Rep. in 2001 to that in 2005?
Make the answer very short. 1.03. What is the ratio of the Persistence rate to the last grade of primary education (%) of Mali in 2001 to that in 2005?
Provide a short and direct response. 1.06. What is the ratio of the Persistence rate to the last grade of primary education (%) in Slovak Republic in 2001 to that in 2005?
Give a very brief answer. 1. What is the ratio of the Persistence rate to the last grade of primary education (%) of Pacific island small states in 2001 to that in 2009?
Keep it short and to the point. 0.92. What is the ratio of the Persistence rate to the last grade of primary education (%) in Mali in 2001 to that in 2009?
Keep it short and to the point. 1.02. What is the ratio of the Persistence rate to the last grade of primary education (%) of Slovak Republic in 2001 to that in 2009?
Your answer should be very brief. 0.99. What is the ratio of the Persistence rate to the last grade of primary education (%) of Pacific island small states in 2002 to that in 2003?
Offer a terse response. 0.97. What is the ratio of the Persistence rate to the last grade of primary education (%) of Egypt, Arab Rep. in 2002 to that in 2003?
Make the answer very short. 0.96. What is the ratio of the Persistence rate to the last grade of primary education (%) of Mali in 2002 to that in 2003?
Offer a very short reply. 0.86. What is the ratio of the Persistence rate to the last grade of primary education (%) in Slovak Republic in 2002 to that in 2003?
Provide a succinct answer. 1.01. What is the ratio of the Persistence rate to the last grade of primary education (%) in Pacific island small states in 2002 to that in 2005?
Provide a short and direct response. 0.97. What is the ratio of the Persistence rate to the last grade of primary education (%) in Egypt, Arab Rep. in 2002 to that in 2005?
Offer a very short reply. 1.02. What is the ratio of the Persistence rate to the last grade of primary education (%) in Mali in 2002 to that in 2005?
Ensure brevity in your answer.  0.93. What is the ratio of the Persistence rate to the last grade of primary education (%) of Slovak Republic in 2002 to that in 2005?
Keep it short and to the point. 1.01. What is the ratio of the Persistence rate to the last grade of primary education (%) in Pacific island small states in 2002 to that in 2009?
Provide a short and direct response. 0.96. What is the ratio of the Persistence rate to the last grade of primary education (%) in Egypt, Arab Rep. in 2002 to that in 2009?
Your answer should be compact. 0.99. What is the ratio of the Persistence rate to the last grade of primary education (%) of Mali in 2002 to that in 2009?
Give a very brief answer. 0.9. What is the ratio of the Persistence rate to the last grade of primary education (%) of Slovak Republic in 2002 to that in 2009?
Your response must be concise. 1. What is the ratio of the Persistence rate to the last grade of primary education (%) in Pacific island small states in 2003 to that in 2005?
Your answer should be very brief. 1. What is the ratio of the Persistence rate to the last grade of primary education (%) in Egypt, Arab Rep. in 2003 to that in 2005?
Provide a succinct answer. 1.07. What is the ratio of the Persistence rate to the last grade of primary education (%) of Mali in 2003 to that in 2005?
Offer a very short reply. 1.09. What is the ratio of the Persistence rate to the last grade of primary education (%) in Pacific island small states in 2003 to that in 2009?
Ensure brevity in your answer.  0.99. What is the ratio of the Persistence rate to the last grade of primary education (%) of Egypt, Arab Rep. in 2003 to that in 2009?
Keep it short and to the point. 1.03. What is the ratio of the Persistence rate to the last grade of primary education (%) in Mali in 2003 to that in 2009?
Offer a terse response. 1.04. What is the ratio of the Persistence rate to the last grade of primary education (%) in Slovak Republic in 2003 to that in 2009?
Your answer should be very brief. 0.99. What is the ratio of the Persistence rate to the last grade of primary education (%) of Pacific island small states in 2005 to that in 2009?
Provide a succinct answer. 0.99. What is the ratio of the Persistence rate to the last grade of primary education (%) of Egypt, Arab Rep. in 2005 to that in 2009?
Make the answer very short. 0.96. What is the ratio of the Persistence rate to the last grade of primary education (%) in Mali in 2005 to that in 2009?
Make the answer very short. 0.96. What is the ratio of the Persistence rate to the last grade of primary education (%) in Slovak Republic in 2005 to that in 2009?
Ensure brevity in your answer.  0.99. What is the difference between the highest and the second highest Persistence rate to the last grade of primary education (%) of Pacific island small states?
Keep it short and to the point. 0.83. What is the difference between the highest and the second highest Persistence rate to the last grade of primary education (%) in Egypt, Arab Rep.?
Ensure brevity in your answer.  0.54. What is the difference between the highest and the second highest Persistence rate to the last grade of primary education (%) in Mali?
Provide a succinct answer. 2.16. What is the difference between the highest and the second highest Persistence rate to the last grade of primary education (%) of Slovak Republic?
Your answer should be very brief. 0.14. What is the difference between the highest and the lowest Persistence rate to the last grade of primary education (%) in Pacific island small states?
Offer a terse response. 6.25. What is the difference between the highest and the lowest Persistence rate to the last grade of primary education (%) in Egypt, Arab Rep.?
Your answer should be compact. 6.61. What is the difference between the highest and the lowest Persistence rate to the last grade of primary education (%) in Mali?
Give a very brief answer. 15.81. What is the difference between the highest and the lowest Persistence rate to the last grade of primary education (%) of Slovak Republic?
Provide a succinct answer. 1.97. 